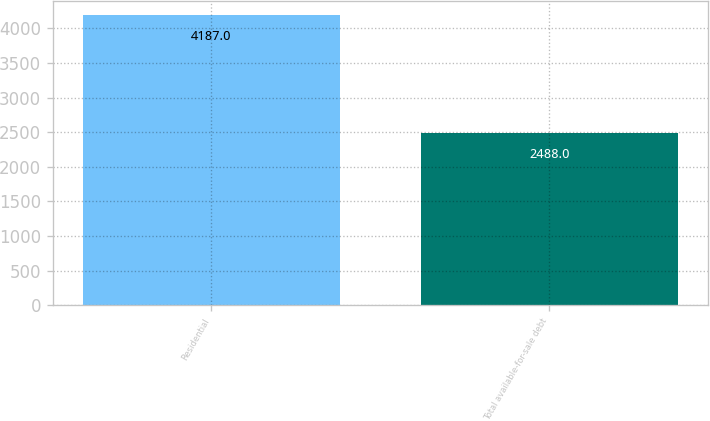Convert chart to OTSL. <chart><loc_0><loc_0><loc_500><loc_500><bar_chart><fcel>Residential<fcel>Total available-for-sale debt<nl><fcel>4187<fcel>2488<nl></chart> 